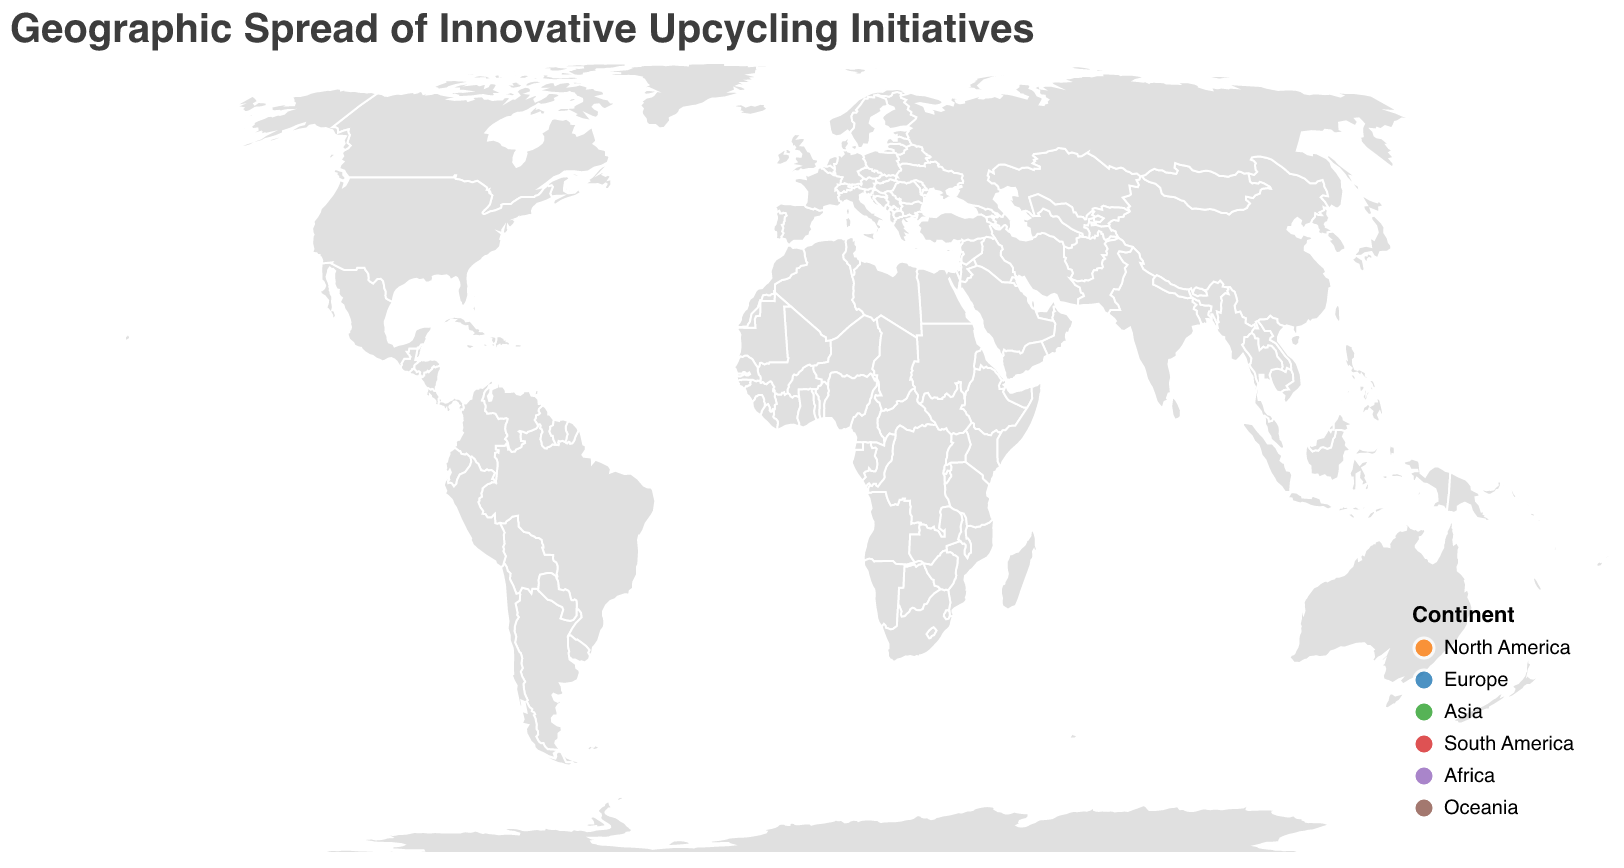What is the title of the plot? The title of the plot is located at the top and is written in a slightly larger font than the rest of the text. It helps to quickly identify the main subject of the plot.
Answer: Geographic Spread of Innovative Upcycling Initiatives What continent has the most entries for upcycling initiatives? By examining the color-coded continents on the map, we can count the number of initiatives from each continent. Europe has the most entries with three initiatives.
Answer: Europe Which city has the highest Impact Score for their upcycling initiative? By looking at the size of the circles and referring to the tooltips for specific scores, we find that Amsterdam in the Netherlands has the highest Impact Score of 9.2.
Answer: Amsterdam What is the approximate latitude and longitude of the initiative in Melbourne, Australia? The initiative in Melbourne, Australia is marked by a circle, and by reading the tooltip that appears when hovering over the circle, we see the coordinates.
Answer: -37.8136, 144.9631 Which initiative has the lowest Impact Score, and what is its score? By examining the sizes of the circles and confirming with the tooltips, we see that the initiative in Santiago, Chile, "Roots of Recycling Art Program," has the lowest Impact Score of 7.5.
Answer: Roots of Recycling Art Program, 7.5 How many initiatives are there in North America? By identifying the initiatives color-coded for North America (in orange), we count the circles representing North America. There are four such initiatives.
Answer: Four Compare the Impact Scores of initiatives in Tokyo and Mumbai. Which one is higher? By checking the sizes of the circles and referring to the tooltips for the scores of initiatives in Tokyo and Mumbai, the initiative in Tokyo has an Impact Score of 7.8, and Mumbai has an Impact Score of 8.0.
Answer: Mumbai Which continent’s initiatives cover the widest range of longitude values? By visually checking the horizontal spread of circles, we can see that the initiatives in Europe (in blue) span a wide range of longitudes from Amsterdam to Berlin to Stockholm.
Answer: Europe What is the average Impact Score for the initiatives in South America? There are two South American initiatives with Impact Scores of 8.1 (São Paulo) and 7.5 (Santiago). The average is calculated as (8.1 + 7.5) / 2 = 7.8.
Answer: 7.8 Which city hosts the initiative named "Wola Nani Recycled Paper Crafts," and what continent is it on? By referring to the tooltip information for each initiative, we find that "Wola Nani Recycled Paper Crafts" is hosted in Cape Town, which is on the continent of Africa.
Answer: Cape Town, Africa 